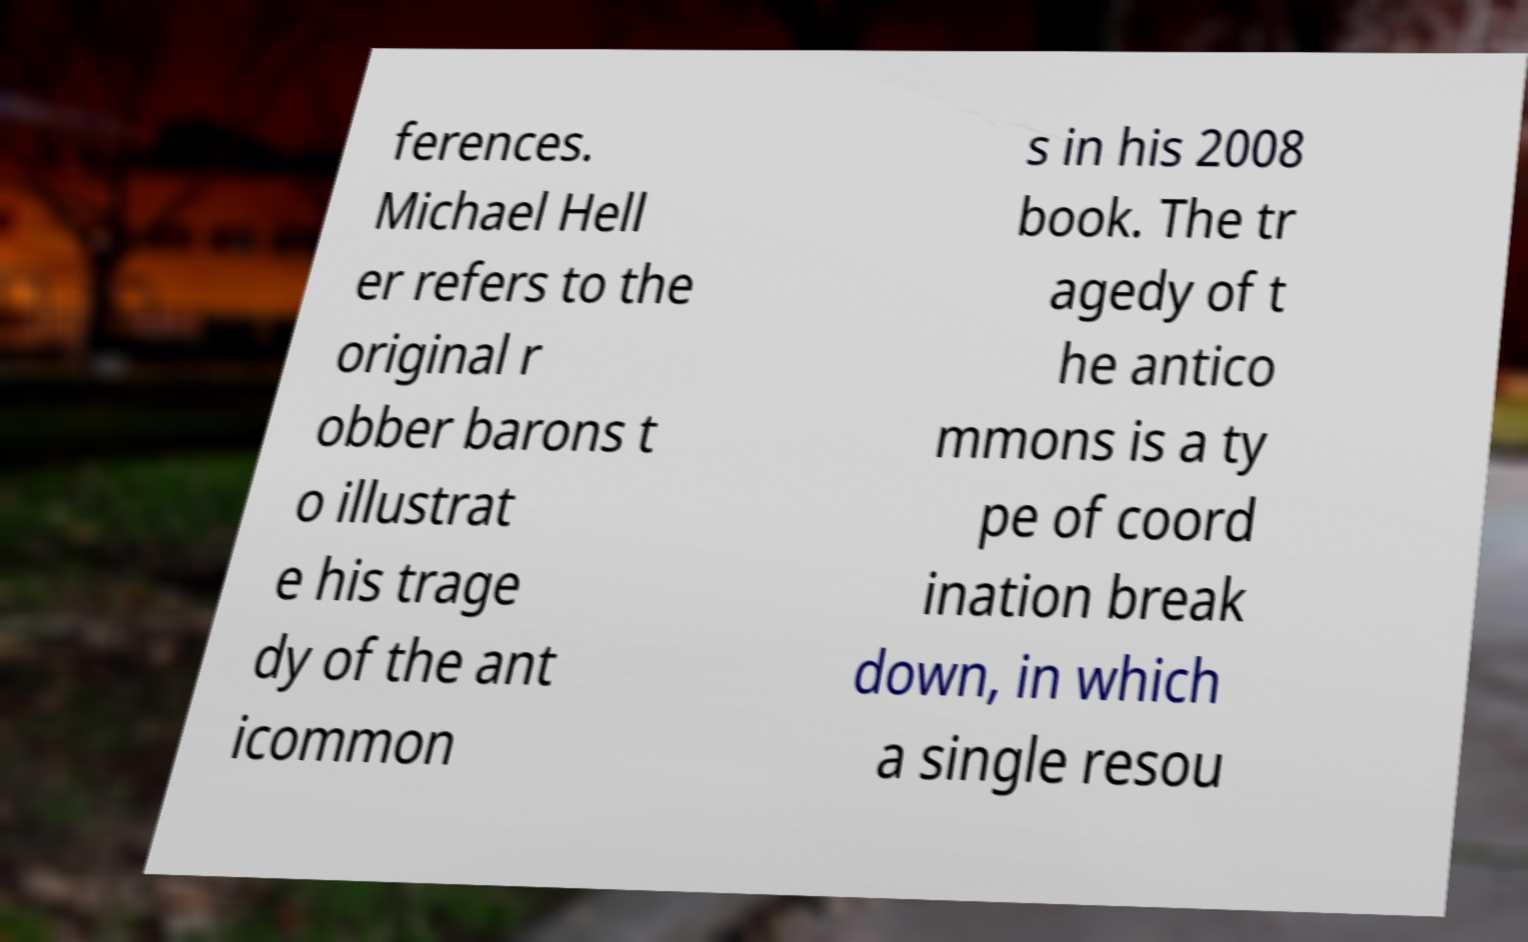Please identify and transcribe the text found in this image. ferences. Michael Hell er refers to the original r obber barons t o illustrat e his trage dy of the ant icommon s in his 2008 book. The tr agedy of t he antico mmons is a ty pe of coord ination break down, in which a single resou 